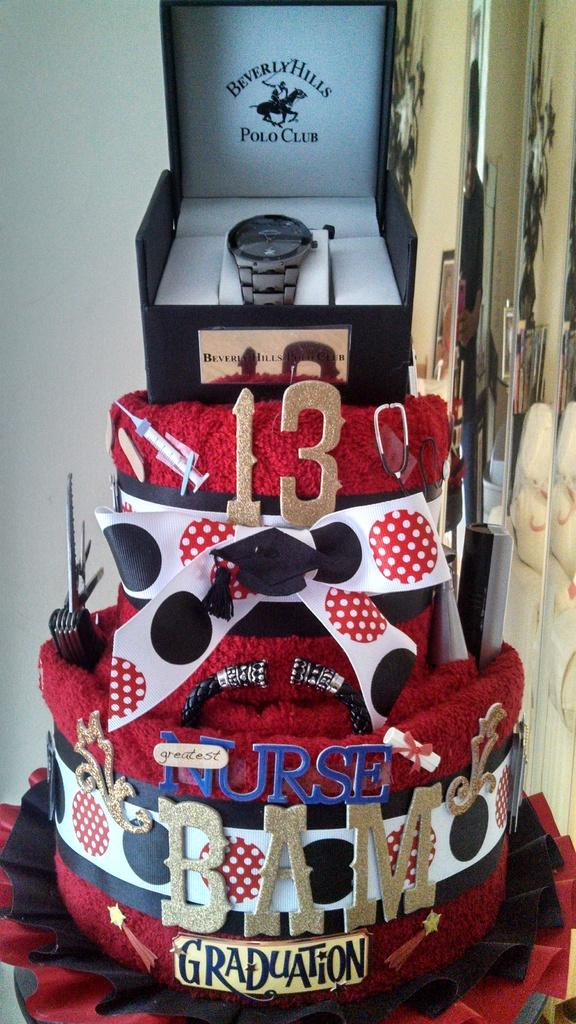<image>
Write a terse but informative summary of the picture. A multi tiered graduation cake is shown with the number 13 on it in gold. 